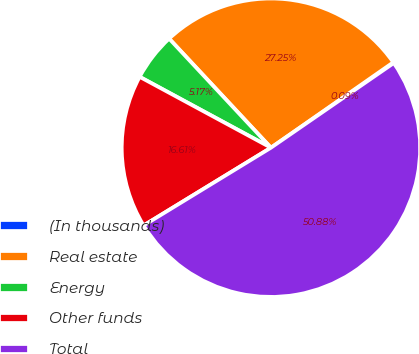Convert chart. <chart><loc_0><loc_0><loc_500><loc_500><pie_chart><fcel>(In thousands)<fcel>Real estate<fcel>Energy<fcel>Other funds<fcel>Total<nl><fcel>0.09%<fcel>27.26%<fcel>5.17%<fcel>16.61%<fcel>50.89%<nl></chart> 